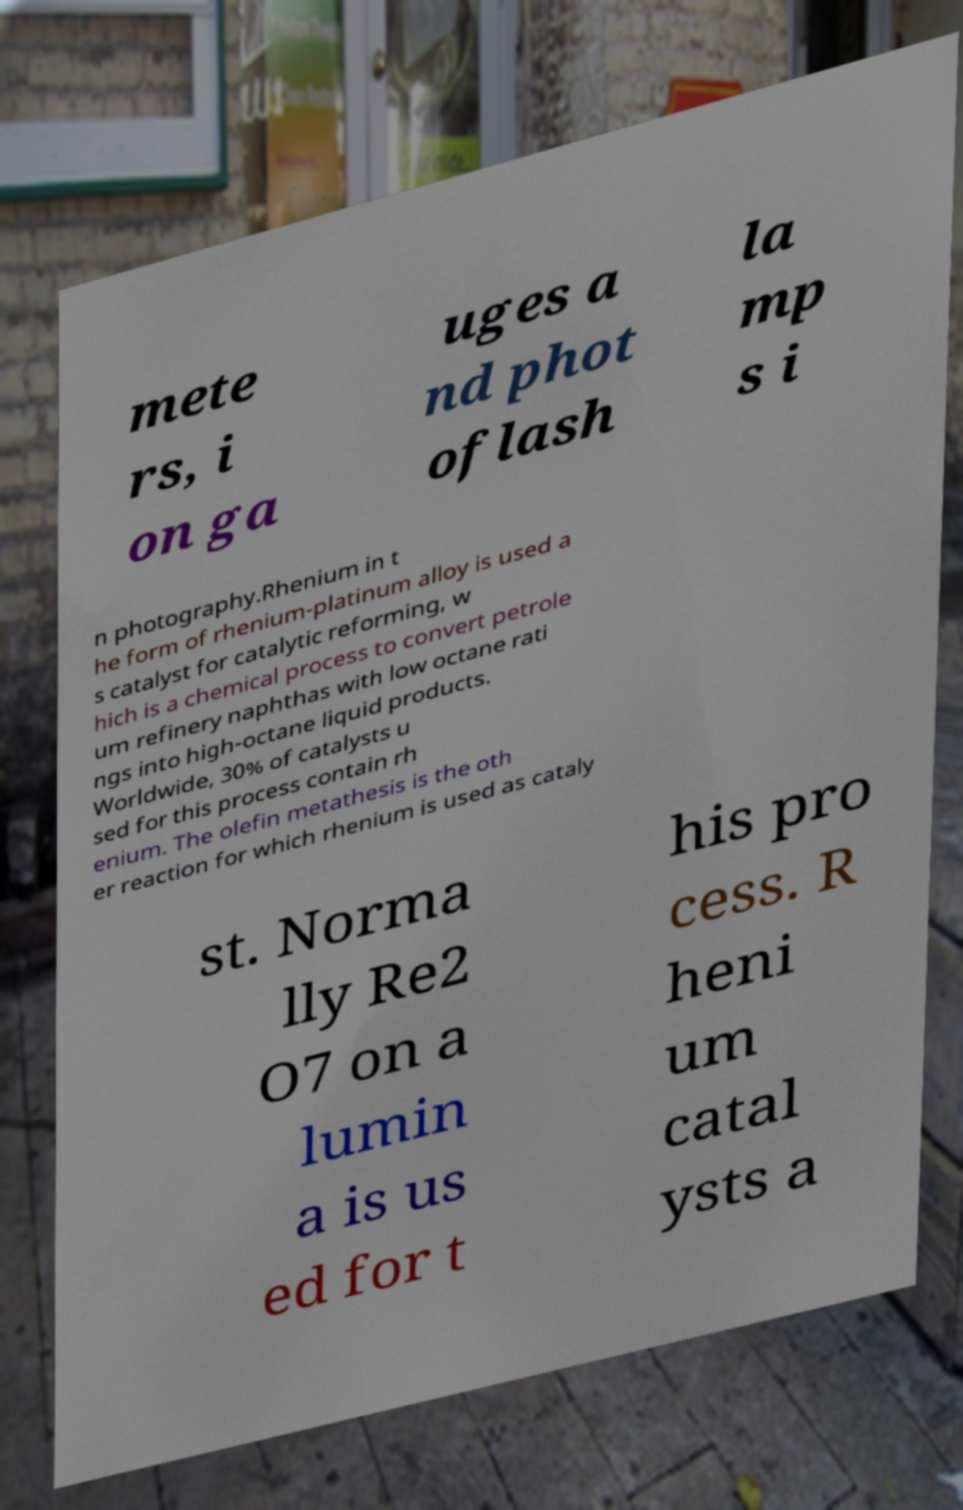Can you accurately transcribe the text from the provided image for me? mete rs, i on ga uges a nd phot oflash la mp s i n photography.Rhenium in t he form of rhenium-platinum alloy is used a s catalyst for catalytic reforming, w hich is a chemical process to convert petrole um refinery naphthas with low octane rati ngs into high-octane liquid products. Worldwide, 30% of catalysts u sed for this process contain rh enium. The olefin metathesis is the oth er reaction for which rhenium is used as cataly st. Norma lly Re2 O7 on a lumin a is us ed for t his pro cess. R heni um catal ysts a 